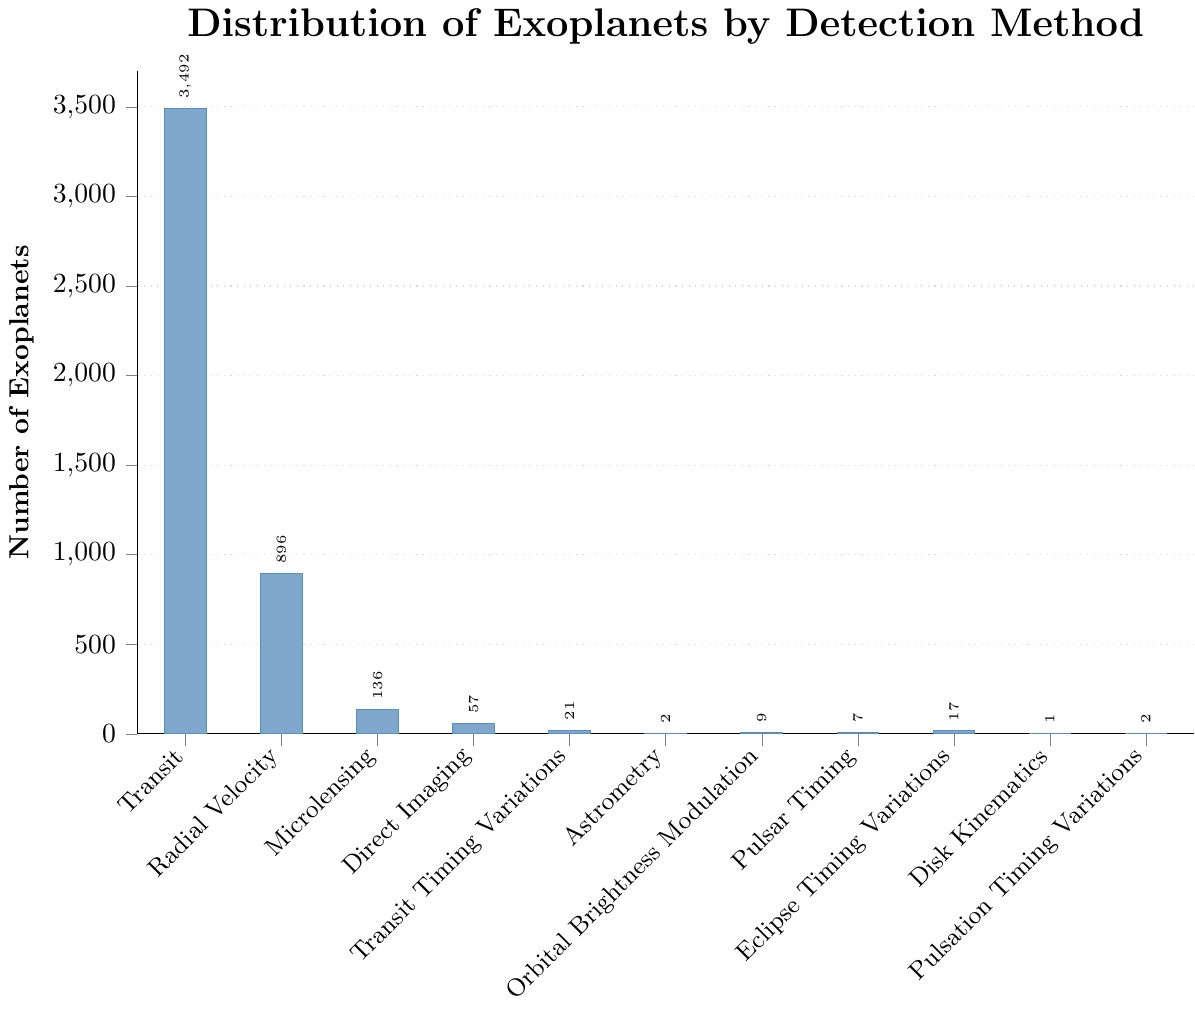How many exoplanets were discovered using Direct Imaging compared to Radial Velocity? According to the figure, Direct Imaging has 57 exoplanets, and Radial Velocity has 896 exoplanets.
Answer: 57 vs 896 Which detection method has the highest number of discovered exoplanets? Observing the bar chart, the highest bar corresponds to the Transit method, which has the highest number of discovered exoplanets at 3492.
Answer: Transit What is the total number of exoplanets discovered using Microlensing, Pulsar Timing, and Astrometry combined? The figure shows Microlensing has 136, Pulsar Timing has 7, and Astrometry has 2. Adding these together: 136 + 7 + 2 = 145.
Answer: 145 How many more exoplanets were discovered using Transit Timing Variations compared to Orbital Brightness Modulation? The chart indicates 21 exoplanets found via Transit Timing Variations and 9 via Orbital Brightness Modulation. The difference is 21 - 9 = 12.
Answer: 12 more What is the ratio of exoplanets discovered using the top three methods compared to the total number? The top three methods are Transit (3492), Radial Velocity (896), and Microlensing (136). Adding them together: 3492 + 896 + 136 = 4524. The total number of exoplanets discovered is the sum of all methods: 3492 + 896 + 136 + 57 + 21 + 2 + 9 + 7 + 17 + 1 + 2 = 4640. The ratio is 4524 / 4640.
Answer: 4524:4640 Which method among Transit, Radial Velocity, and Direct Imaging discovered the least number of exoplanets? Among the three methods, Direct Imaging discovered the least number of exoplanets with only 57.
Answer: Direct Imaging If you sum up the exoplanets discovered using methods other than Transit, what is the total? The number of exoplanets discovered using non-Transit methods are Radial Velocity (896), Microlensing (136), Direct Imaging (57), Transit Timing Variations (21), Astrometry (2), Orbital Brightness Modulation (9), Pulsar Timing (7), Eclipse Timing Variations (17), Disk Kinematics (1), Pulsation Timing Variations (2). Adding them together: 896 + 136 + 57 + 21 + 2 + 9 + 7 + 17 + 1 + 2 = 1148.
Answer: 1148 What is the average number of exoplanets discovered using methods with fewer than 20 detections? Methods with fewer than 20 detections are Astrometry (2), Orbital Brightness Modulation (9), Pulsar Timing (7), Eclipse Timing Variations (17), Disk Kinematics (1), and Pulsation Timing Variations (2). The sum is 2 + 9 + 7 + 17 + 1 + 2 = 38. There are 6 methods, so the average is 38 / 6.
Answer: 6.33 